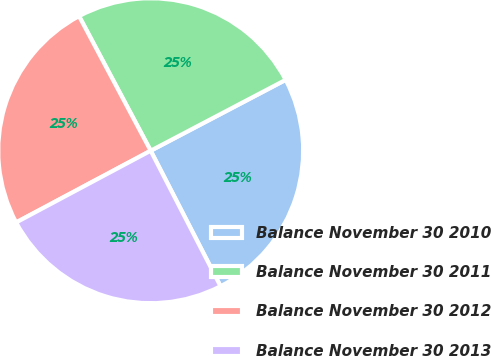<chart> <loc_0><loc_0><loc_500><loc_500><pie_chart><fcel>Balance November 30 2010<fcel>Balance November 30 2011<fcel>Balance November 30 2012<fcel>Balance November 30 2013<nl><fcel>25.12%<fcel>25.09%<fcel>25.01%<fcel>24.78%<nl></chart> 